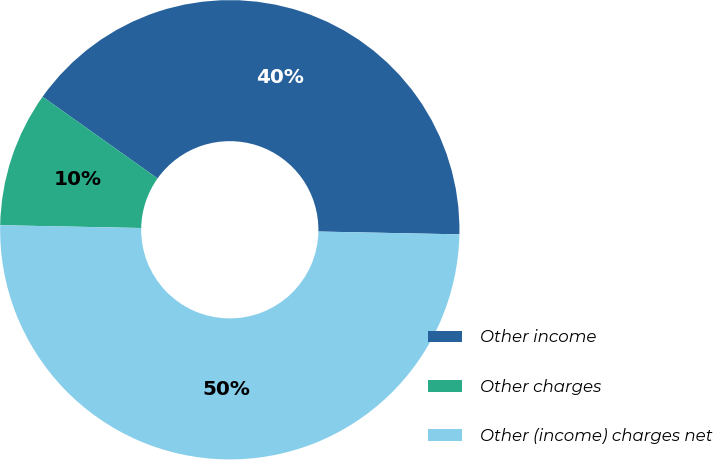Convert chart to OTSL. <chart><loc_0><loc_0><loc_500><loc_500><pie_chart><fcel>Other income<fcel>Other charges<fcel>Other (income) charges net<nl><fcel>40.48%<fcel>9.52%<fcel>50.0%<nl></chart> 